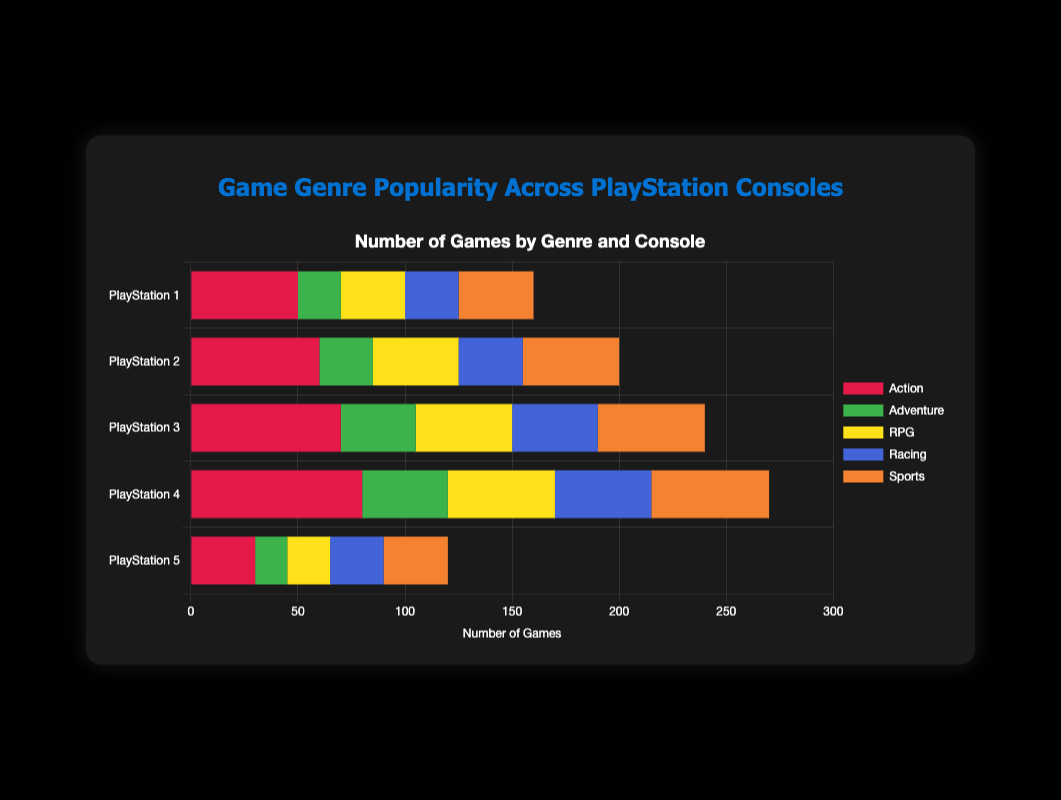What genre has the most games on PlayStation 4? Find the "PlayStation 4" bar group and check the genre with the longest bar, which is "Action".
Answer: Action Which console has the highest number of "RPG" games? Compare the length of the "RPG" bars across all consoles. The longest "RPG" bar is for "PlayStation 4".
Answer: PlayStation 4 How many more "Sports" games are there on PlayStation 4 compared to PlayStation 1? Locate the "Sports" bars for both "PlayStation 4" and "PlayStation 1". Subtract the value for "PlayStation 1" (35) from "PlayStation 4" (55).
Answer: 20 What is the total number of "Racing" games across all consoles? Sum the lengths of all "Racing" bars: 25 (PS1) + 30 (PS2) + 40 (PS3) + 45 (PS4) + 25 (PS5) = 165
Answer: 165 Which console has the least number of total games? Sum the lengths of all genre bars for each console and compare. "PlayStation 5" has the shortest cumulative length.
Answer: PlayStation 5 Between "Action" and "Adventure" genres on PlayStation 3, which has more games and by how many? Compare the lengths of the "Action" and "Adventure" bars for "PlayStation 3". "Action" (70) is longer than "Adventure" (35). The difference is 70 - 35.
Answer: Action by 35 How many genres on PlayStation 2 have more than 30 games? Count the genres for "PlayStation 2" where the bar length (number of games) exceeds 30. These are "Action" (60), "RPG" (40), and "Sports" (45).
Answer: 3 Which genre saw the most significant decrease in the number of games from PlayStation 4 to PlayStation 5? Compare the bars of all genres between "PlayStation 4" and "PlayStation 5" and find the maximum decrease: "Action" decreased from 80 to 30, a reduction of 50.
Answer: Action Which console has the most balanced number of games across all genres? Compare the lengths of all genre bars for each console to see which has the most similar lengths. "PlayStation 2" has relatively balanced bar lengths across genres.
Answer: PlayStation 2 